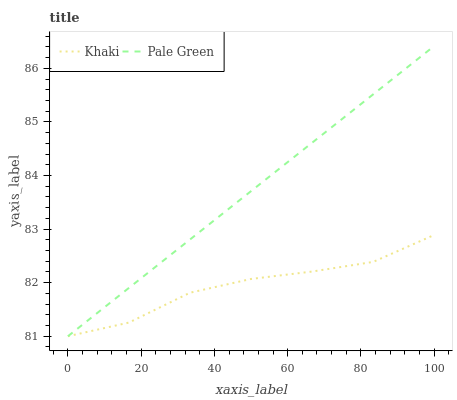Does Khaki have the minimum area under the curve?
Answer yes or no. Yes. Does Pale Green have the maximum area under the curve?
Answer yes or no. Yes. Does Khaki have the maximum area under the curve?
Answer yes or no. No. Is Pale Green the smoothest?
Answer yes or no. Yes. Is Khaki the roughest?
Answer yes or no. Yes. Is Khaki the smoothest?
Answer yes or no. No. Does Pale Green have the lowest value?
Answer yes or no. Yes. Does Pale Green have the highest value?
Answer yes or no. Yes. Does Khaki have the highest value?
Answer yes or no. No. Does Pale Green intersect Khaki?
Answer yes or no. Yes. Is Pale Green less than Khaki?
Answer yes or no. No. Is Pale Green greater than Khaki?
Answer yes or no. No. 